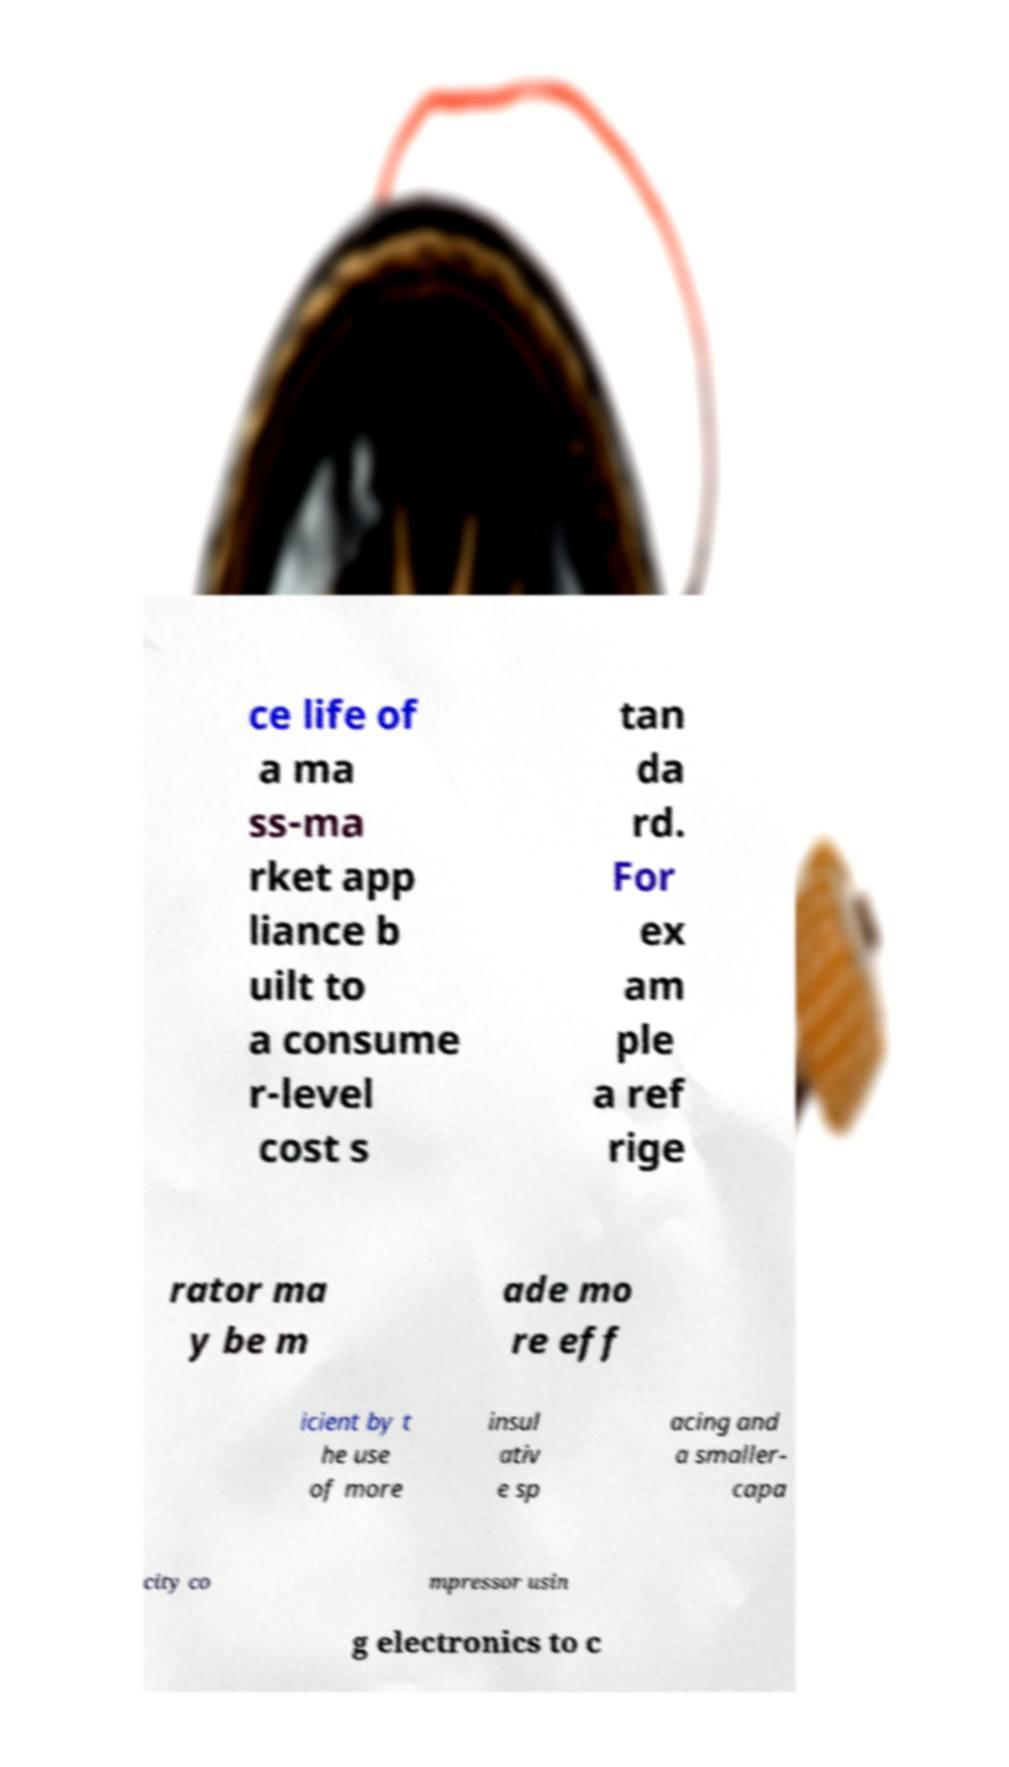For documentation purposes, I need the text within this image transcribed. Could you provide that? ce life of a ma ss-ma rket app liance b uilt to a consume r-level cost s tan da rd. For ex am ple a ref rige rator ma y be m ade mo re eff icient by t he use of more insul ativ e sp acing and a smaller- capa city co mpressor usin g electronics to c 